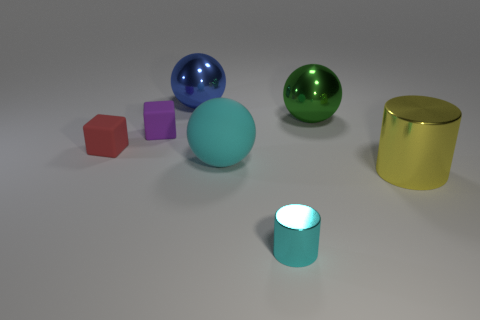Subtract all large green spheres. How many spheres are left? 2 Add 2 red rubber things. How many objects exist? 9 Subtract all cyan spheres. How many spheres are left? 2 Subtract 2 balls. How many balls are left? 1 Subtract all cubes. How many objects are left? 5 Add 5 large green objects. How many large green objects are left? 6 Add 1 tiny purple rubber things. How many tiny purple rubber things exist? 2 Subtract 0 blue cylinders. How many objects are left? 7 Subtract all green spheres. Subtract all blue cylinders. How many spheres are left? 2 Subtract all tiny purple cubes. Subtract all shiny cylinders. How many objects are left? 4 